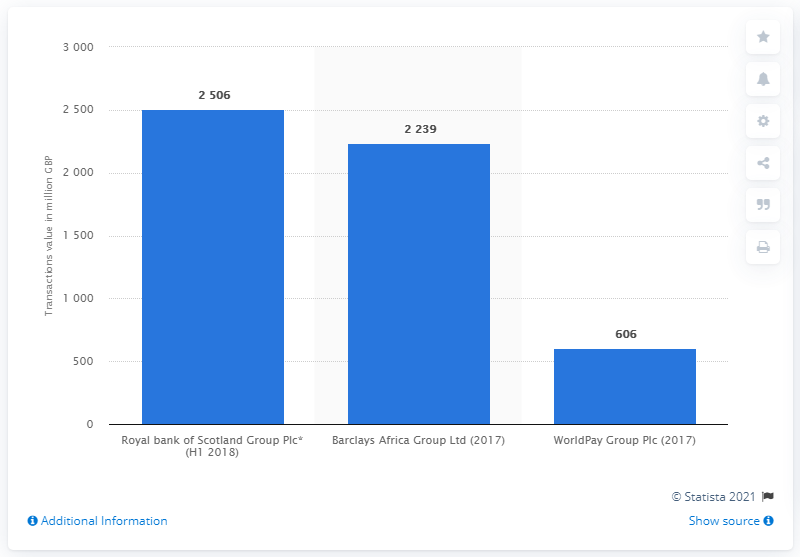Mention a couple of crucial points in this snapshot. The divestiture of The Royal Bank of Scotland Group Plc between 2017 and 2018 was valued at approximately 2506. 